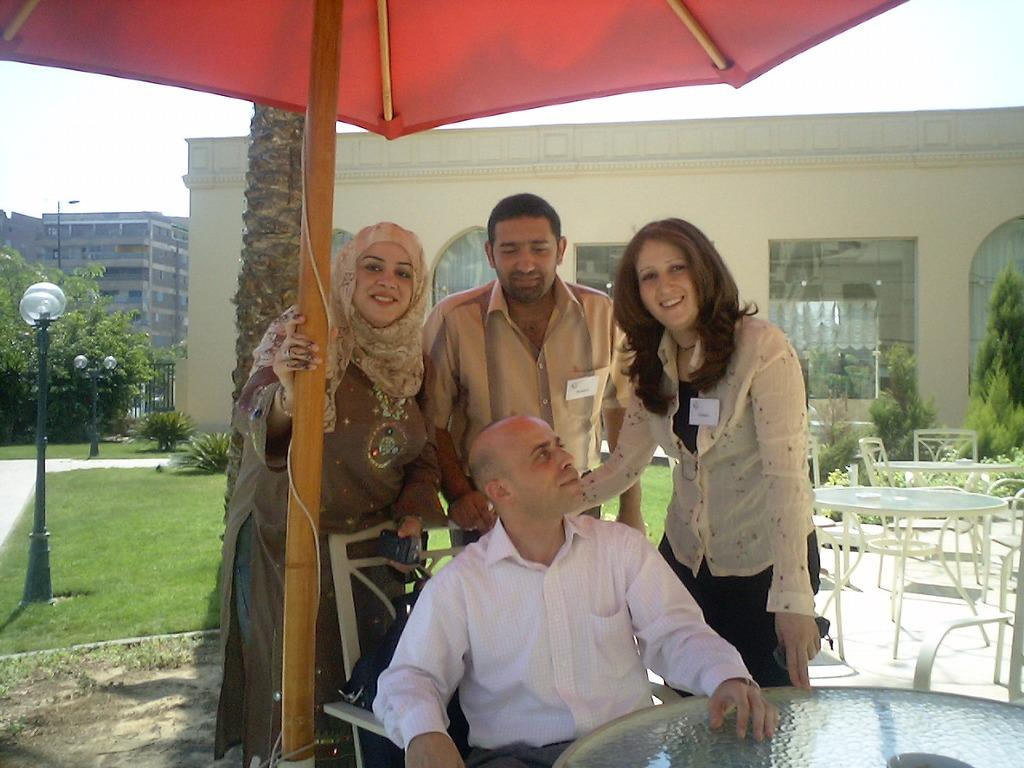What is the man in the image doing? The man is sitting on a chair in the image. What is providing shade for the man in the image? The man is under an umbrella. What is the man wearing in the image? The man is wearing a white shirt. How many people are standing behind the man in the image? There are three people standing behind the man in the image. What is the facial expression of the people standing behind the man? The people are smiling. What can be seen in the background of the image? There is a building and trees in the background of the image. What type of wrench is the man using to fix the flower in the image? There is no wrench or flower present in the image. Can you confirm the existence of the man in the image? Yes, the man is sitting on a chair in the image. 